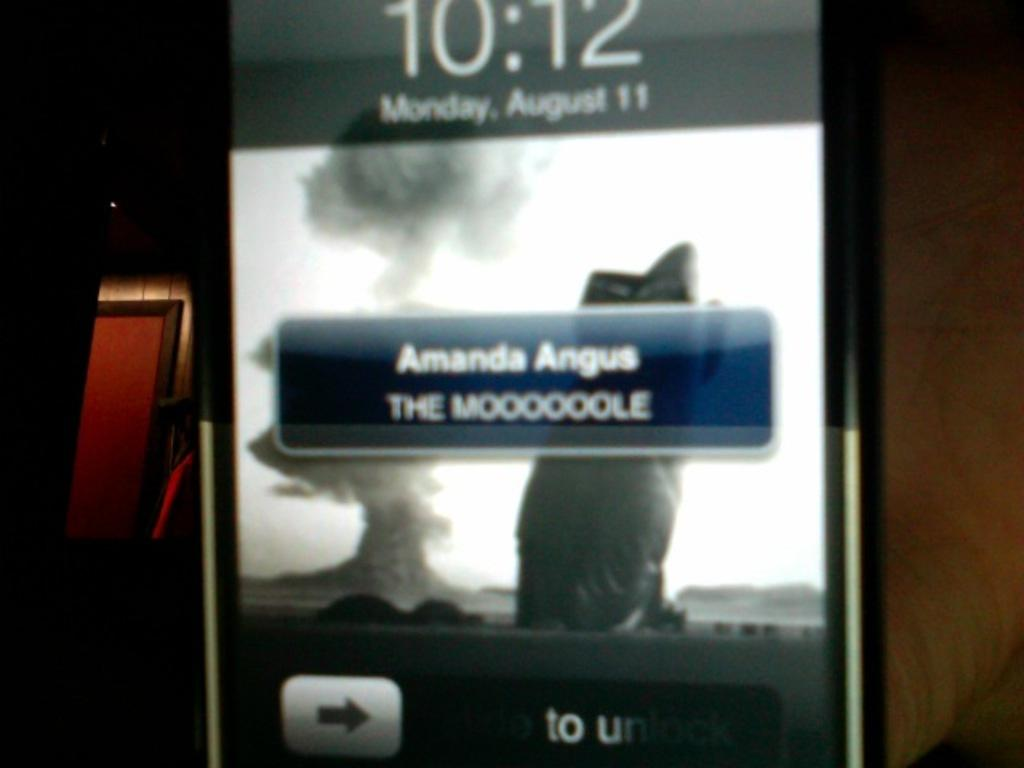<image>
Provide a brief description of the given image. A phone screen shows a message from Amanda Angus. 